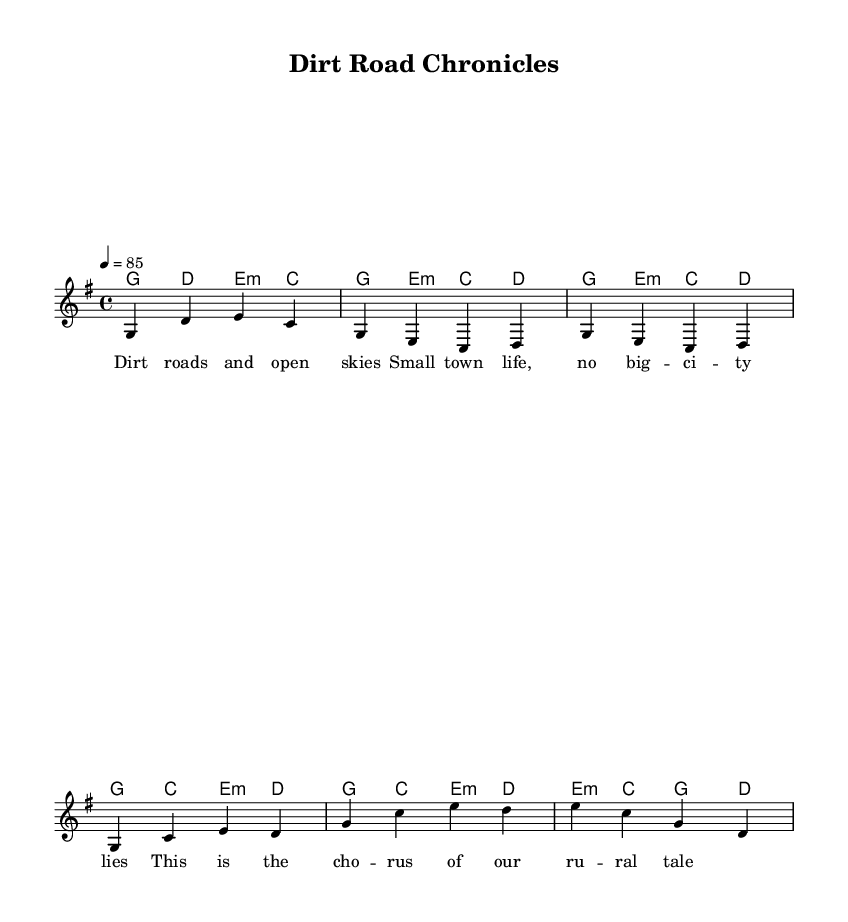What is the key signature of this music? The key signature is G major, which includes an F sharp. This can be observed at the beginning of the staff, where the key signature indicates the sharps present.
Answer: G major What is the time signature of this music? The time signature is 4/4, which can be found at the beginning of the score. This indicates that each measure contains four beats, and the quarter note gets one beat.
Answer: 4/4 What is the tempo marking of this music? The tempo marking is indicated as 4 = 85, which means that there are 85 beats per minute. This is usually found in the header or tempo indication of the music.
Answer: 85 How many measures are there in the first verse? The first verse consists of two measures, which can be counted from the melody section provided, focusing on the first set of notes related to the verse lyrics.
Answer: 2 What type of music is this considered? This music is considered to be a storytelling rap because it combines typical rap lyricism with a musical structure that features verses and a chorus, reflecting life in rural America.
Answer: Storytelling rap What chords are used in the chorus? The chords in the chorus are G, C, E minor, and D. These can be seen in the harmonies section aligned with the corresponding melody notes in the chorus lyrics.
Answer: G, C, E minor, D What is the primary theme of the lyrics in this music? The primary theme of the lyrics revolves around rural life, reflecting experiences and stories from dirt roads and small-town living. The lyrics capture a sense of place and identity inherent in rural America.
Answer: Rural life 